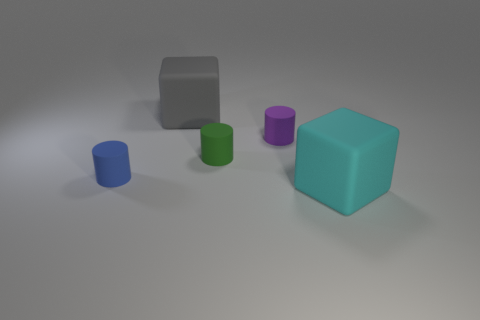Are there any small purple rubber spheres? I have carefully examined the image and can confirm that there are no purple rubber spheres present, small or otherwise. 